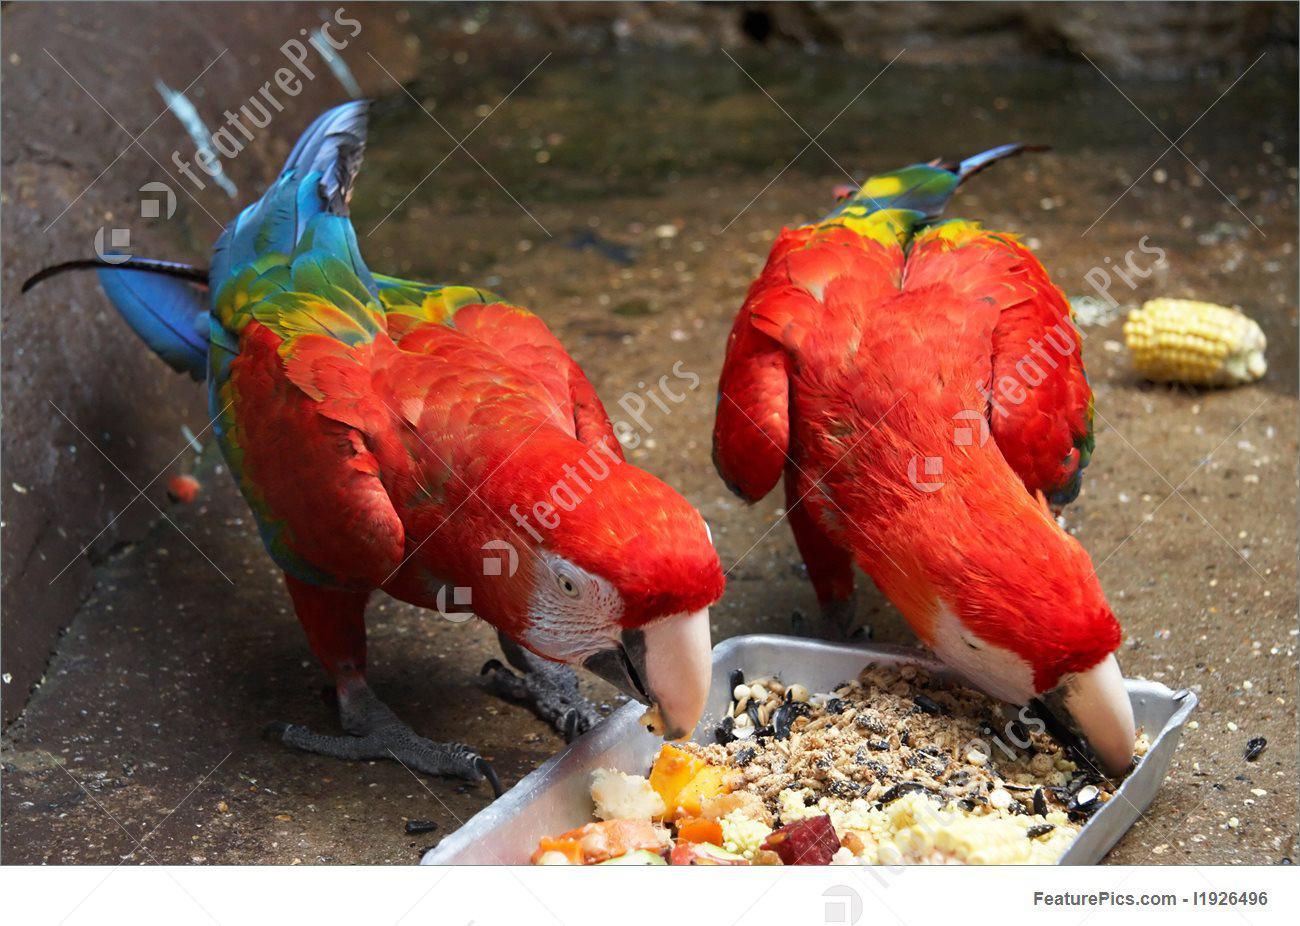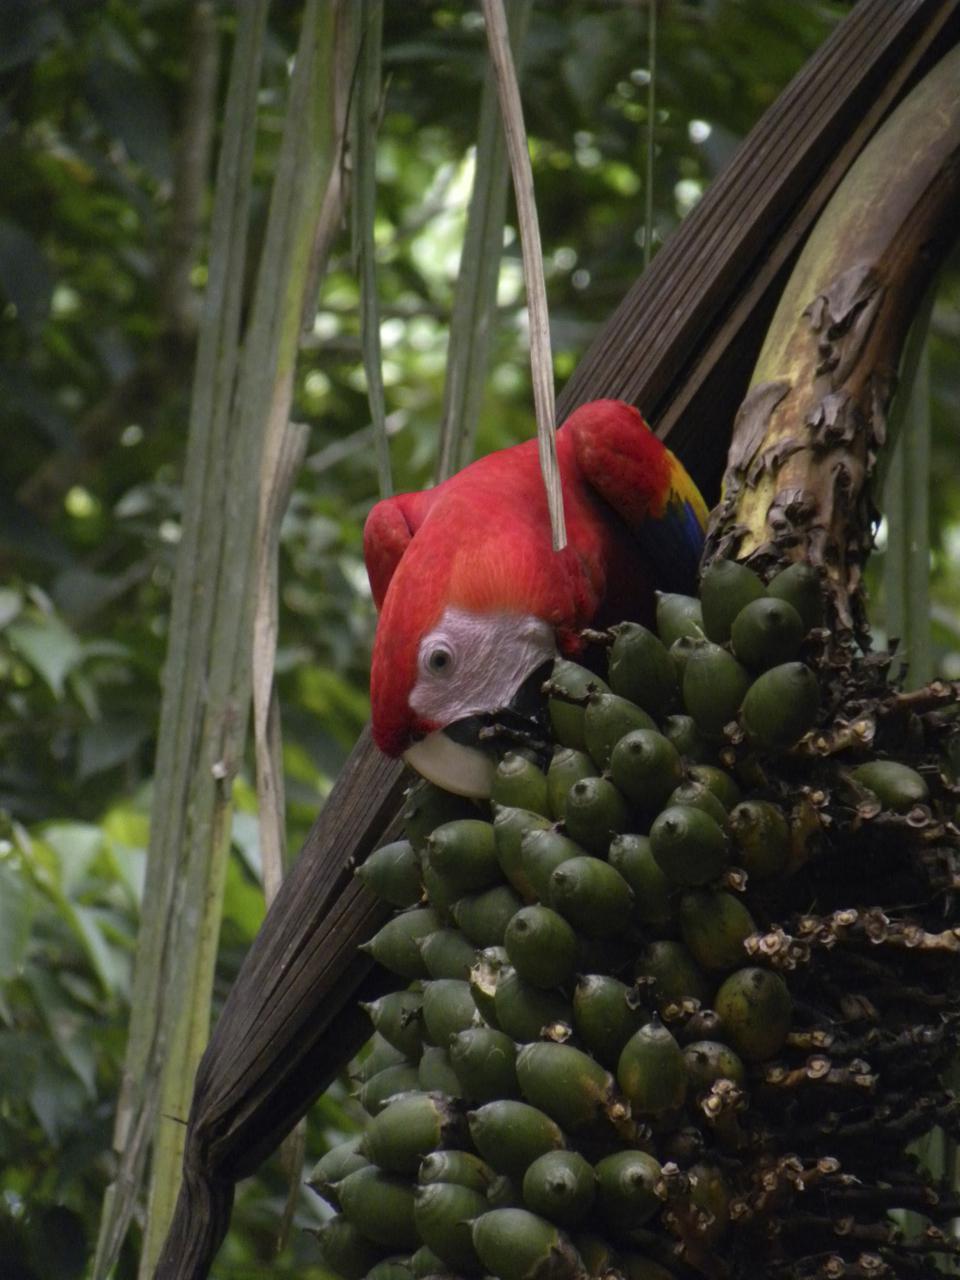The first image is the image on the left, the second image is the image on the right. Assess this claim about the two images: "All of the birds in the images are sitting in the branches of trees.". Correct or not? Answer yes or no. No. The first image is the image on the left, the second image is the image on the right. Considering the images on both sides, is "There are no more than three birds in the pair of images." valid? Answer yes or no. Yes. 